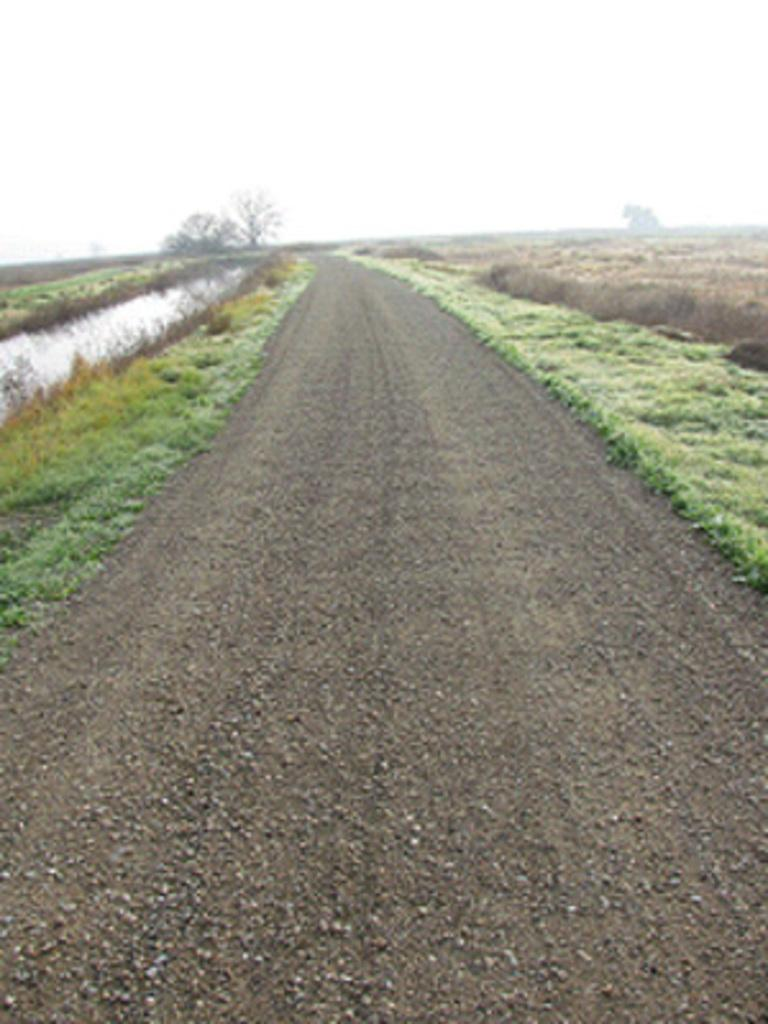What type of vegetation can be seen in the image? There are trees in the image. What covers the ground in the image? The ground is covered with plants. What can be seen besides the vegetation in the image? There is water visible in the image. What type of man-made structure is present in the image? There is a road in the image. What is visible at the top of the image? The sky is visible at the top of the image. How many goldfish can be seen swimming in the water in the image? There are no goldfish present in the image; it only features trees, plants, water, a road, and the sky. 